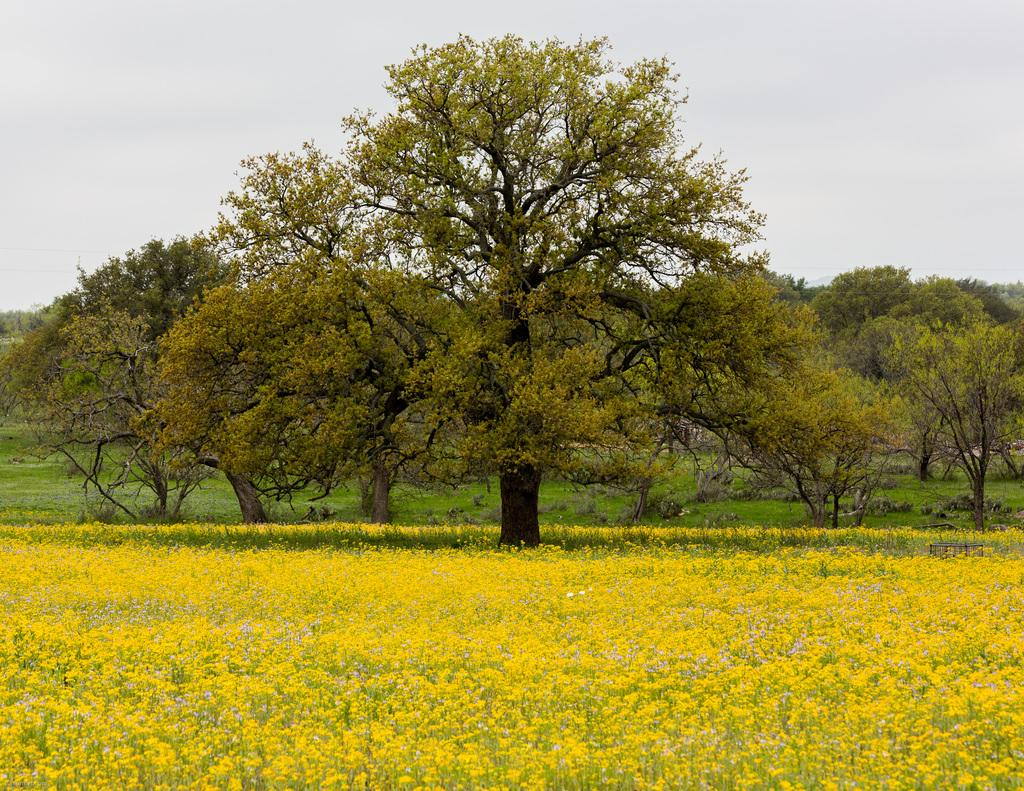What type of living organisms can be seen in the image? Plants, flowers, and trees are visible in the image. What type of vegetation is present in the image? Grass is present in the image. What is visible in the background of the image? The sky is visible in the image. What type of calendar is hanging on the wire in the image? There is no calendar or wire present in the image. How quiet is the environment in the image? The provided facts do not give any information about the noise level in the image, so it cannot be determined from the image. 